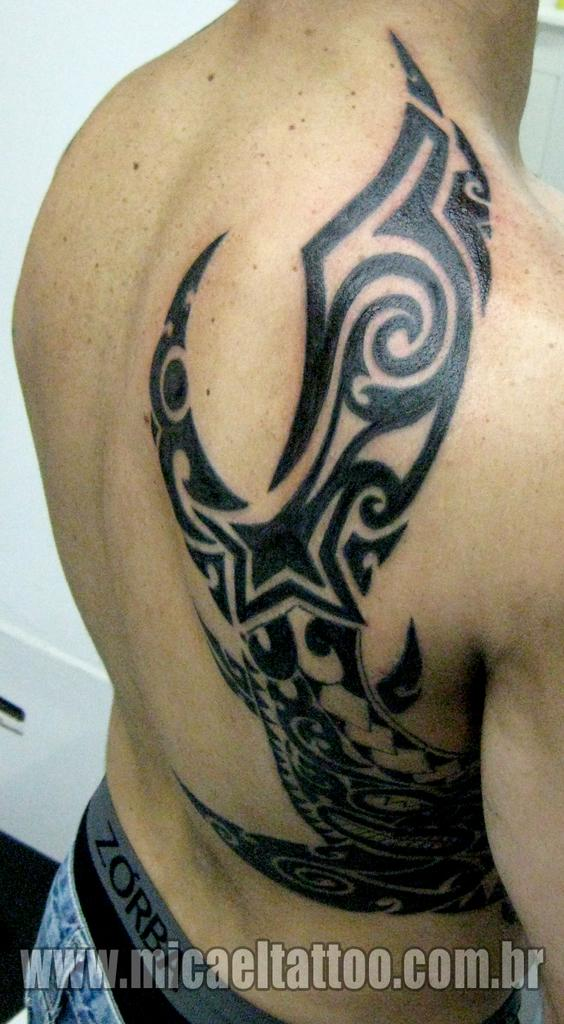What is visible on the body of the person in the image? There is a tattoo on the body of a person in the image. What can be found at the bottom of the image? There is some text written at the bottom of the image. What type of hill can be seen in the background of the image? There is no hill visible in the image; it only features a tattoo on a person's body and some text at the bottom. 